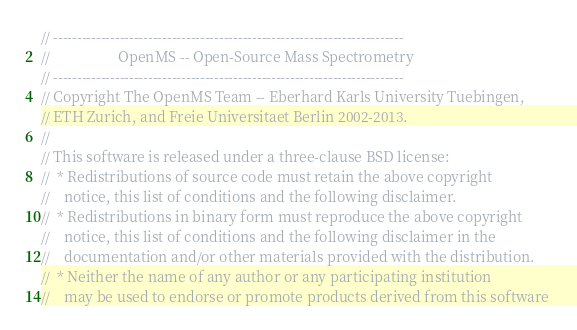<code> <loc_0><loc_0><loc_500><loc_500><_C++_>// --------------------------------------------------------------------------
//                   OpenMS -- Open-Source Mass Spectrometry               
// --------------------------------------------------------------------------
// Copyright The OpenMS Team -- Eberhard Karls University Tuebingen,
// ETH Zurich, and Freie Universitaet Berlin 2002-2013.
// 
// This software is released under a three-clause BSD license:
//  * Redistributions of source code must retain the above copyright
//    notice, this list of conditions and the following disclaimer.
//  * Redistributions in binary form must reproduce the above copyright
//    notice, this list of conditions and the following disclaimer in the
//    documentation and/or other materials provided with the distribution.
//  * Neither the name of any author or any participating institution 
//    may be used to endorse or promote products derived from this software </code> 